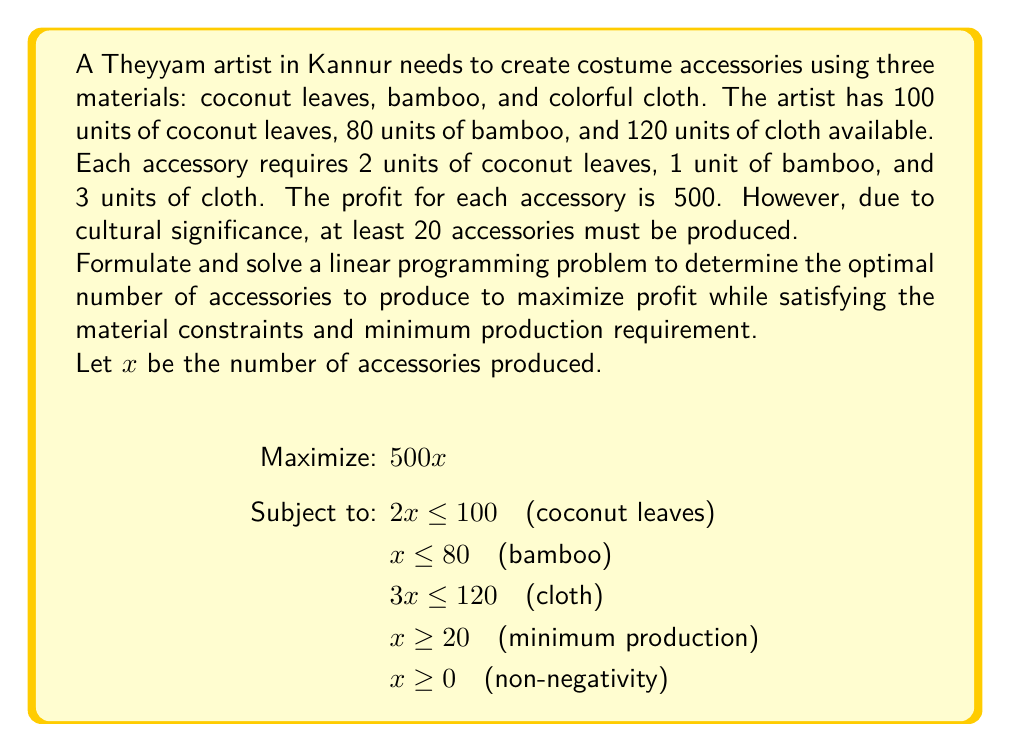Help me with this question. To solve this linear programming problem, we'll follow these steps:

1) Identify the binding constraints:
   - Coconut leaves: $2x \leq 100$ or $x \leq 50$
   - Bamboo: $x \leq 80$
   - Cloth: $3x \leq 120$ or $x \leq 40$
   - Minimum production: $x \geq 20$

2) The most restrictive upper bound is $x \leq 40$ (from the cloth constraint).

3) The lower bound is $x \geq 20$ (minimum production requirement).

4) Therefore, the feasible region is $20 \leq x \leq 40$.

5) Since the objective function $500x$ is increasing in $x$, the optimal solution will be at the upper bound of the feasible region.

6) Thus, the optimal solution is $x = 40$.

7) The maximum profit is:
   $500 \times 40 = ₹20,000$

8) Check if this solution satisfies all constraints:
   - Coconut leaves: $2 \times 40 = 80 \leq 100$ (satisfied)
   - Bamboo: $40 \leq 80$ (satisfied)
   - Cloth: $3 \times 40 = 120 \leq 120$ (satisfied)
   - Minimum production: $40 \geq 20$ (satisfied)

Therefore, the optimal solution is to produce 40 accessories, which will yield a maximum profit of ₹20,000 while satisfying all constraints.
Answer: 40 accessories; ₹20,000 profit 